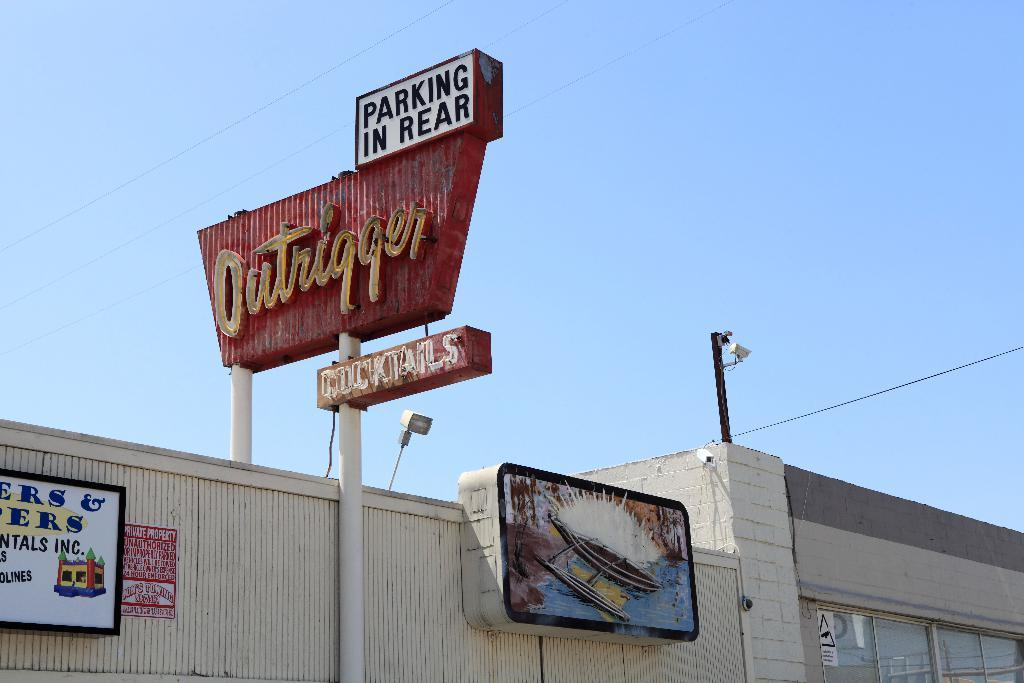Provide a one-sentence caption for the provided image. The Outrigger restaurant has a sign that reads both Cocktails and parking in the rear. 